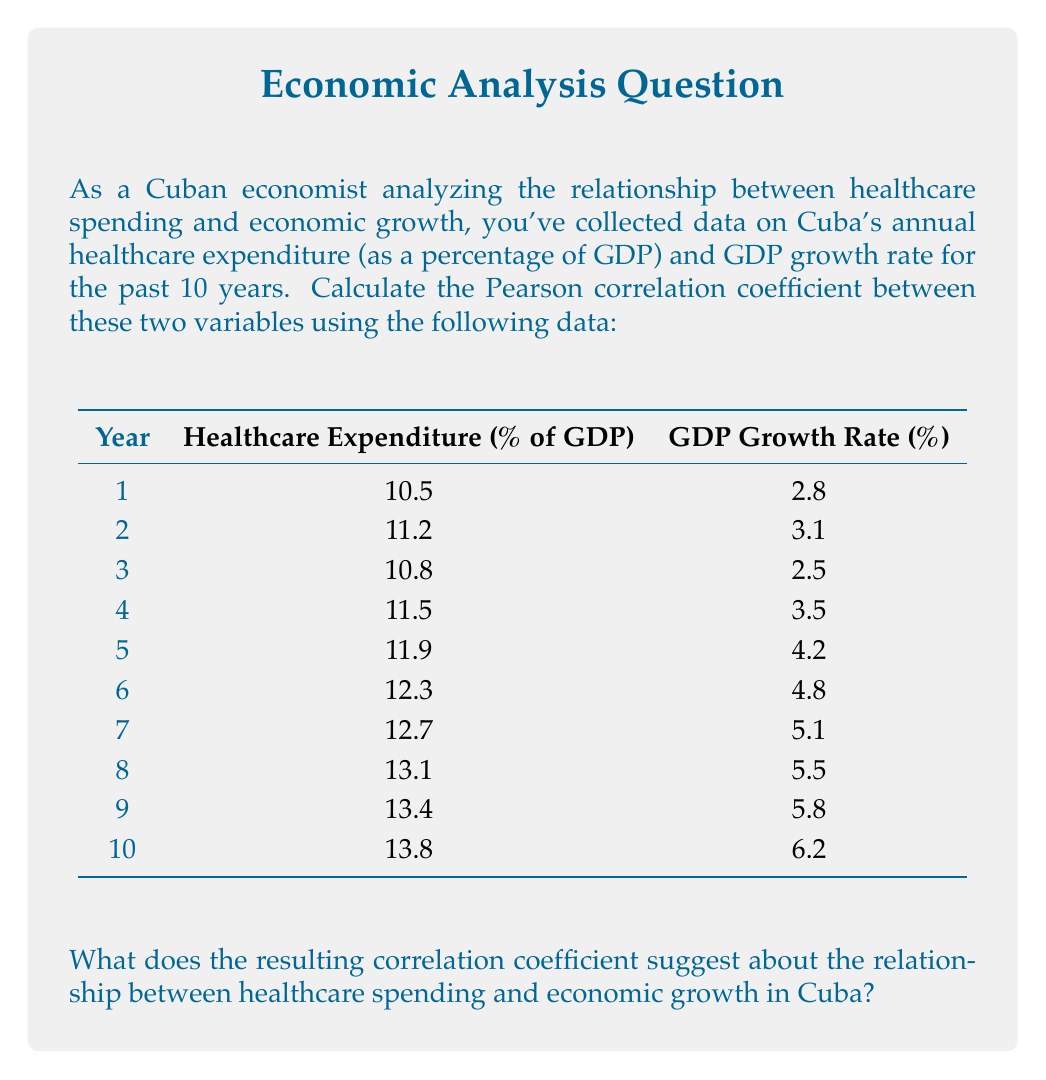Help me with this question. To calculate the Pearson correlation coefficient between healthcare expenditure and GDP growth rate, we'll follow these steps:

1. Calculate the means of both variables:
   Let $x$ be healthcare expenditure and $y$ be GDP growth rate.
   
   $\bar{x} = \frac{\sum_{i=1}^{n} x_i}{n} = \frac{121.2}{10} = 12.12$
   
   $\bar{y} = \frac{\sum_{i=1}^{n} y_i}{n} = \frac{43.5}{10} = 4.35$

2. Calculate the deviations from the mean for each variable:
   $x_i - \bar{x}$ and $y_i - \bar{y}$

3. Calculate the products of these deviations:
   $(x_i - \bar{x})(y_i - \bar{y})$

4. Sum the products of deviations:
   $\sum_{i=1}^{n} (x_i - \bar{x})(y_i - \bar{y})$

5. Calculate the sum of squared deviations for each variable:
   $\sum_{i=1}^{n} (x_i - \bar{x})^2$ and $\sum_{i=1}^{n} (y_i - \bar{y})^2$

6. Apply the Pearson correlation coefficient formula:

   $$r = \frac{\sum_{i=1}^{n} (x_i - \bar{x})(y_i - \bar{y})}{\sqrt{\sum_{i=1}^{n} (x_i - \bar{x})^2 \sum_{i=1}^{n} (y_i - \bar{y})^2}}$$

Calculations:
$\sum_{i=1}^{n} (x_i - \bar{x})(y_i - \bar{y}) = 13.494$
$\sum_{i=1}^{n} (x_i - \bar{x})^2 = 14.886$
$\sum_{i=1}^{n} (y_i - \bar{y})^2 = 18.015$

Substituting into the formula:

$$r = \frac{13.494}{\sqrt{14.886 \times 18.015}} = \frac{13.494}{16.375} = 0.824$$

The Pearson correlation coefficient is approximately 0.824.

Interpretation:
A correlation coefficient of 0.824 indicates a strong positive correlation between healthcare expenditure and GDP growth rate in Cuba. This suggests that as healthcare spending increases, there is a tendency for economic growth to increase as well. However, it's important to note that correlation does not imply causation, and other factors may contribute to this relationship.
Answer: The Pearson correlation coefficient between healthcare expenditure and GDP growth rate in Cuba is approximately 0.824, indicating a strong positive correlation between healthcare spending and economic growth. 